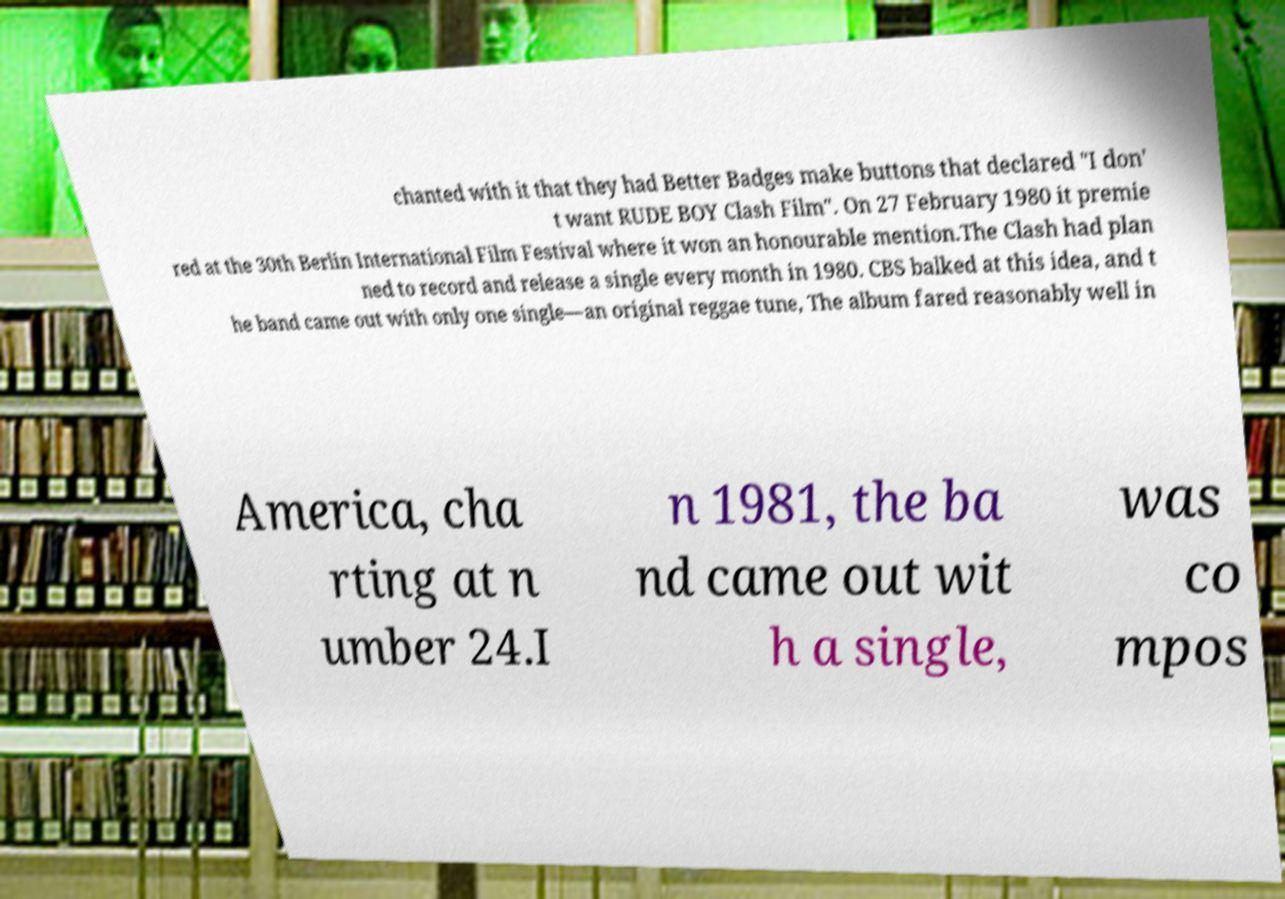Could you assist in decoding the text presented in this image and type it out clearly? chanted with it that they had Better Badges make buttons that declared "I don' t want RUDE BOY Clash Film". On 27 February 1980 it premie red at the 30th Berlin International Film Festival where it won an honourable mention.The Clash had plan ned to record and release a single every month in 1980. CBS balked at this idea, and t he band came out with only one single—an original reggae tune, The album fared reasonably well in America, cha rting at n umber 24.I n 1981, the ba nd came out wit h a single, was co mpos 